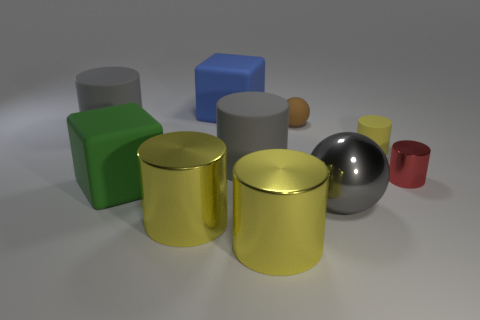Subtract all yellow cylinders. How many were subtracted if there are1yellow cylinders left? 2 Subtract all brown blocks. How many yellow cylinders are left? 3 Subtract 3 cylinders. How many cylinders are left? 3 Subtract all gray cylinders. How many cylinders are left? 4 Subtract all large gray cylinders. How many cylinders are left? 4 Subtract all red cylinders. Subtract all yellow blocks. How many cylinders are left? 5 Subtract all cylinders. How many objects are left? 4 Subtract all big brown rubber spheres. Subtract all large matte objects. How many objects are left? 6 Add 6 blue things. How many blue things are left? 7 Add 5 gray metal things. How many gray metal things exist? 6 